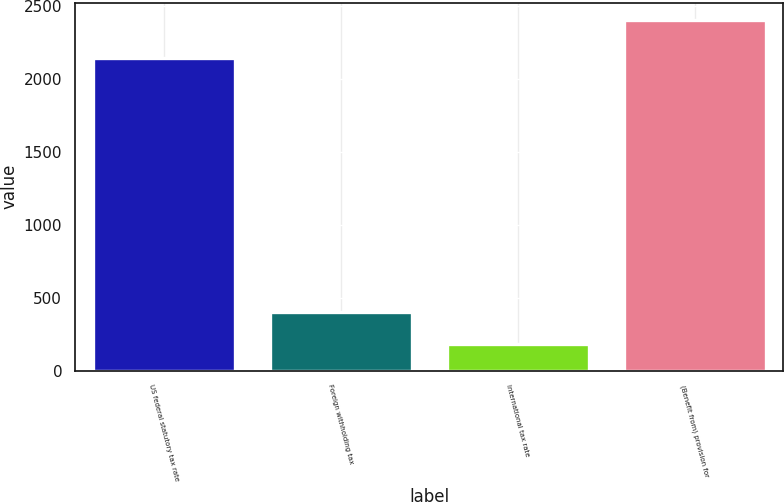Convert chart. <chart><loc_0><loc_0><loc_500><loc_500><bar_chart><fcel>US federal statutory tax rate<fcel>Foreign withholding tax<fcel>International tax rate<fcel>(Benefit from) provision for<nl><fcel>2139<fcel>405.6<fcel>184<fcel>2400<nl></chart> 